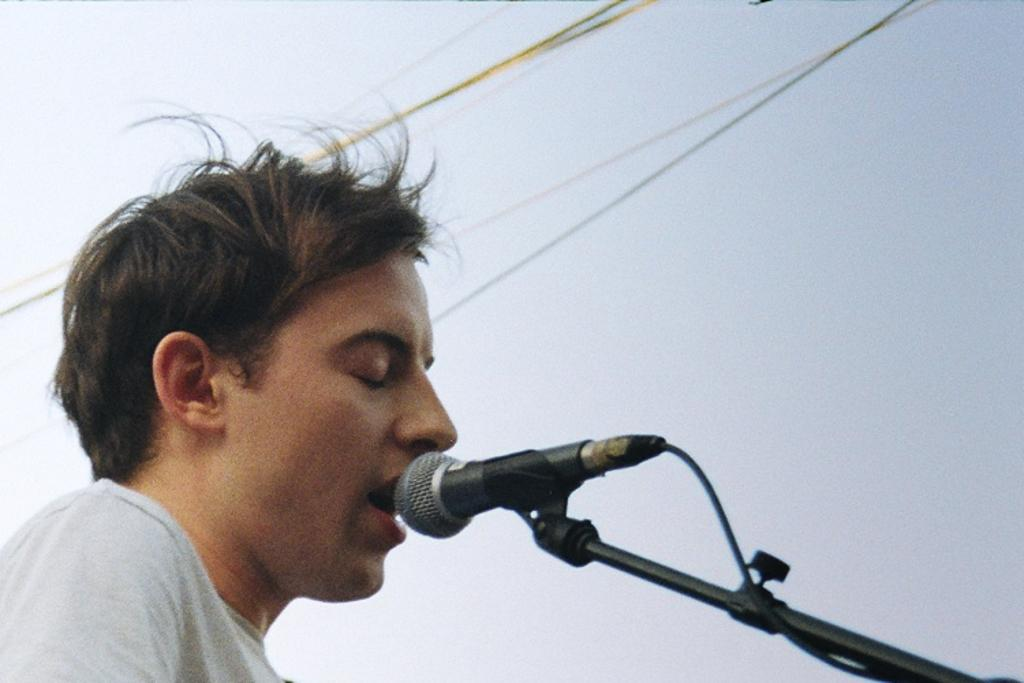What is on the left side of the image? There is a person on the left side of the image. What is the person wearing? A: The person is wearing a t-shirt. What is the person doing in the image? The person is singing. What object is the person using to amplify their voice? There is a microphone in the image, which is attached to a black color stand. What can be seen in the background of the image? There are cables and the sky visible in the background of the image. What page of the notebook is the person writing on in the image? There is no notebook present in the image; the person is singing with a microphone. What color is the person's tongue in the image? The color of the person's tongue is not visible in the image, as the focus is on their singing and the microphone. 